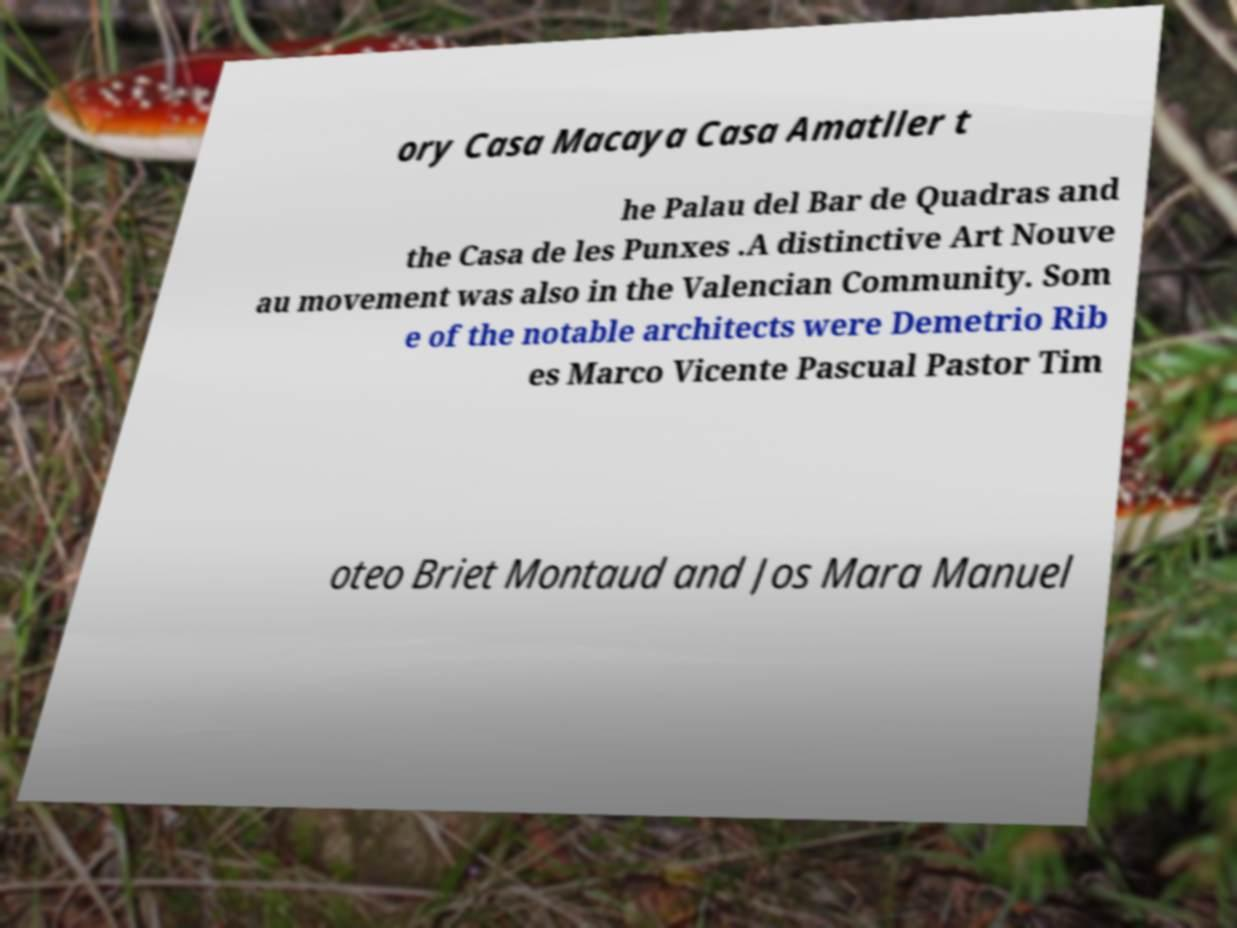For documentation purposes, I need the text within this image transcribed. Could you provide that? ory Casa Macaya Casa Amatller t he Palau del Bar de Quadras and the Casa de les Punxes .A distinctive Art Nouve au movement was also in the Valencian Community. Som e of the notable architects were Demetrio Rib es Marco Vicente Pascual Pastor Tim oteo Briet Montaud and Jos Mara Manuel 